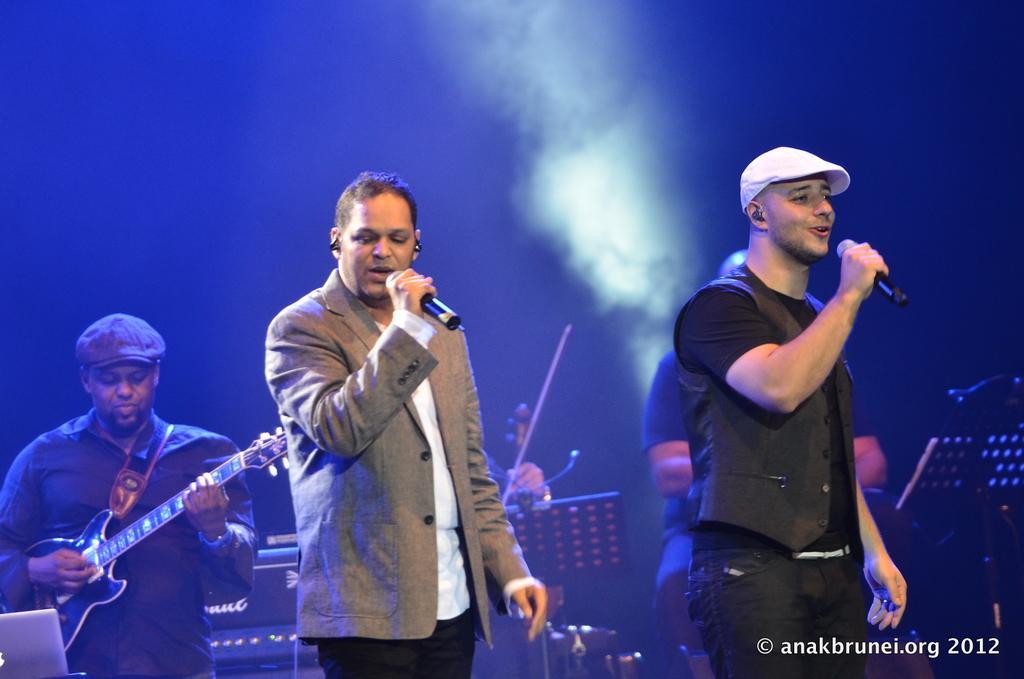Could you give a brief overview of what you see in this image? In this image, few peoples are playing a musical instrument. Two are holding microphone on his hands. Right side person is wearing a cap on his head. These two peoples are singing. 